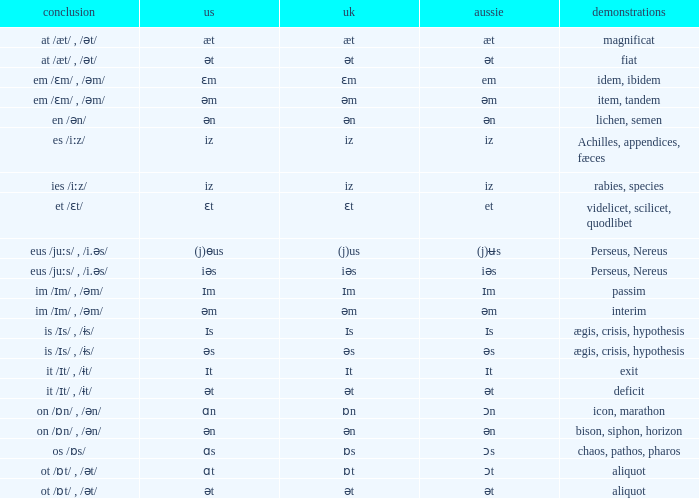Could you parse the entire table? {'header': ['conclusion', 'us', 'uk', 'aussie', 'demonstrations'], 'rows': [['at /æt/ , /ət/', 'æt', 'æt', 'æt', 'magnificat'], ['at /æt/ , /ət/', 'ət', 'ət', 'ət', 'fiat'], ['em /ɛm/ , /əm/', 'ɛm', 'ɛm', 'em', 'idem, ibidem'], ['em /ɛm/ , /əm/', 'əm', 'əm', 'əm', 'item, tandem'], ['en /ən/', 'ən', 'ən', 'ən', 'lichen, semen'], ['es /iːz/', 'iz', 'iz', 'iz', 'Achilles, appendices, fæces'], ['ies /iːz/', 'iz', 'iz', 'iz', 'rabies, species'], ['et /ɛt/', 'ɛt', 'ɛt', 'et', 'videlicet, scilicet, quodlibet'], ['eus /juːs/ , /i.əs/', '(j)ɵus', '(j)us', '(j)ʉs', 'Perseus, Nereus'], ['eus /juːs/ , /i.əs/', 'iəs', 'iəs', 'iəs', 'Perseus, Nereus'], ['im /ɪm/ , /əm/', 'ɪm', 'ɪm', 'ɪm', 'passim'], ['im /ɪm/ , /əm/', 'əm', 'əm', 'əm', 'interim'], ['is /ɪs/ , /ɨs/', 'ɪs', 'ɪs', 'ɪs', 'ægis, crisis, hypothesis'], ['is /ɪs/ , /ɨs/', 'əs', 'əs', 'əs', 'ægis, crisis, hypothesis'], ['it /ɪt/ , /ɨt/', 'ɪt', 'ɪt', 'ɪt', 'exit'], ['it /ɪt/ , /ɨt/', 'ət', 'ət', 'ət', 'deficit'], ['on /ɒn/ , /ən/', 'ɑn', 'ɒn', 'ɔn', 'icon, marathon'], ['on /ɒn/ , /ən/', 'ən', 'ən', 'ən', 'bison, siphon, horizon'], ['os /ɒs/', 'ɑs', 'ɒs', 'ɔs', 'chaos, pathos, pharos'], ['ot /ɒt/ , /ət/', 'ɑt', 'ɒt', 'ɔt', 'aliquot'], ['ot /ɒt/ , /ət/', 'ət', 'ət', 'ət', 'aliquot']]} Which American has British of ɛm? Ɛm. 